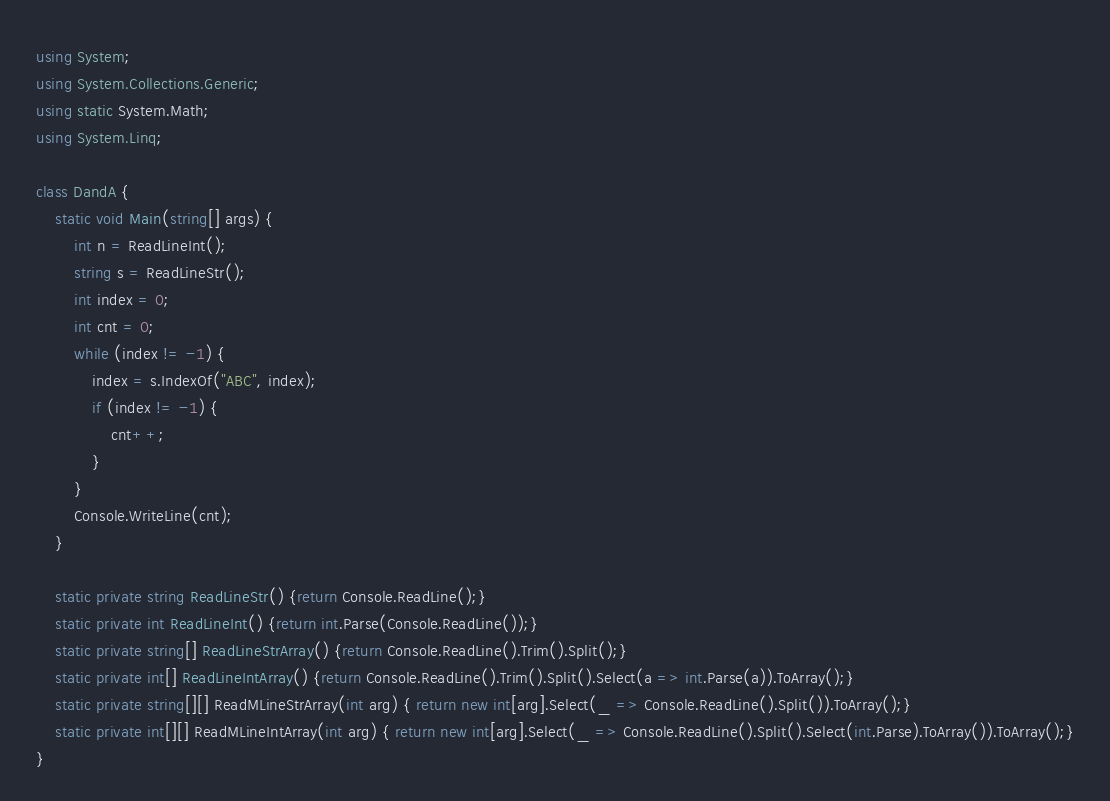<code> <loc_0><loc_0><loc_500><loc_500><_C#_>using System;
using System.Collections.Generic;
using static System.Math;
using System.Linq;
 
class DandA {
    static void Main(string[] args) {
        int n = ReadLineInt();
        string s = ReadLineStr();
        int index = 0;
        int cnt = 0;
        while (index != -1) {
            index = s.IndexOf("ABC", index);
            if (index != -1) {
                cnt++;
            }
        }
        Console.WriteLine(cnt);
    }
  
    static private string ReadLineStr() {return Console.ReadLine();}
    static private int ReadLineInt() {return int.Parse(Console.ReadLine());}
    static private string[] ReadLineStrArray() {return Console.ReadLine().Trim().Split();}
    static private int[] ReadLineIntArray() {return Console.ReadLine().Trim().Split().Select(a => int.Parse(a)).ToArray();}
    static private string[][] ReadMLineStrArray(int arg) { return new int[arg].Select(_ => Console.ReadLine().Split()).ToArray();}
    static private int[][] ReadMLineIntArray(int arg) { return new int[arg].Select(_ => Console.ReadLine().Split().Select(int.Parse).ToArray()).ToArray();}
}</code> 